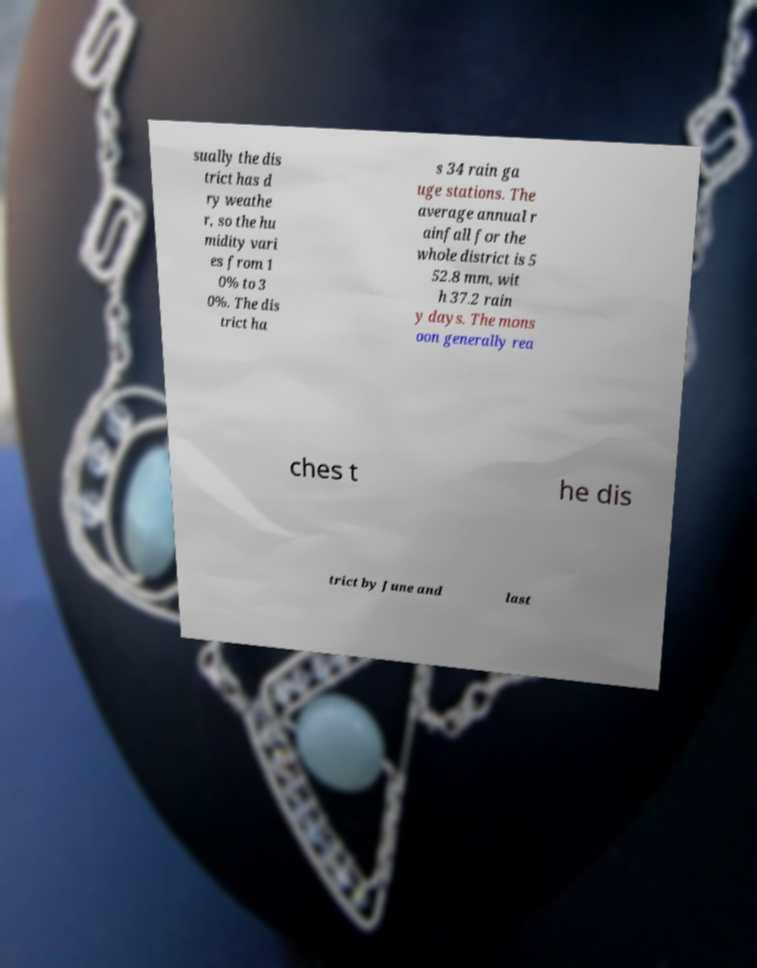For documentation purposes, I need the text within this image transcribed. Could you provide that? sually the dis trict has d ry weathe r, so the hu midity vari es from 1 0% to 3 0%. The dis trict ha s 34 rain ga uge stations. The average annual r ainfall for the whole district is 5 52.8 mm, wit h 37.2 rain y days. The mons oon generally rea ches t he dis trict by June and last 